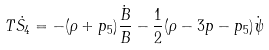Convert formula to latex. <formula><loc_0><loc_0><loc_500><loc_500>T \dot { S _ { 4 } } = - ( \rho + p _ { 5 } ) \frac { \dot { B } } { B } - \frac { 1 } { 2 } ( \rho - 3 p - p _ { 5 } ) \dot { \psi }</formula> 